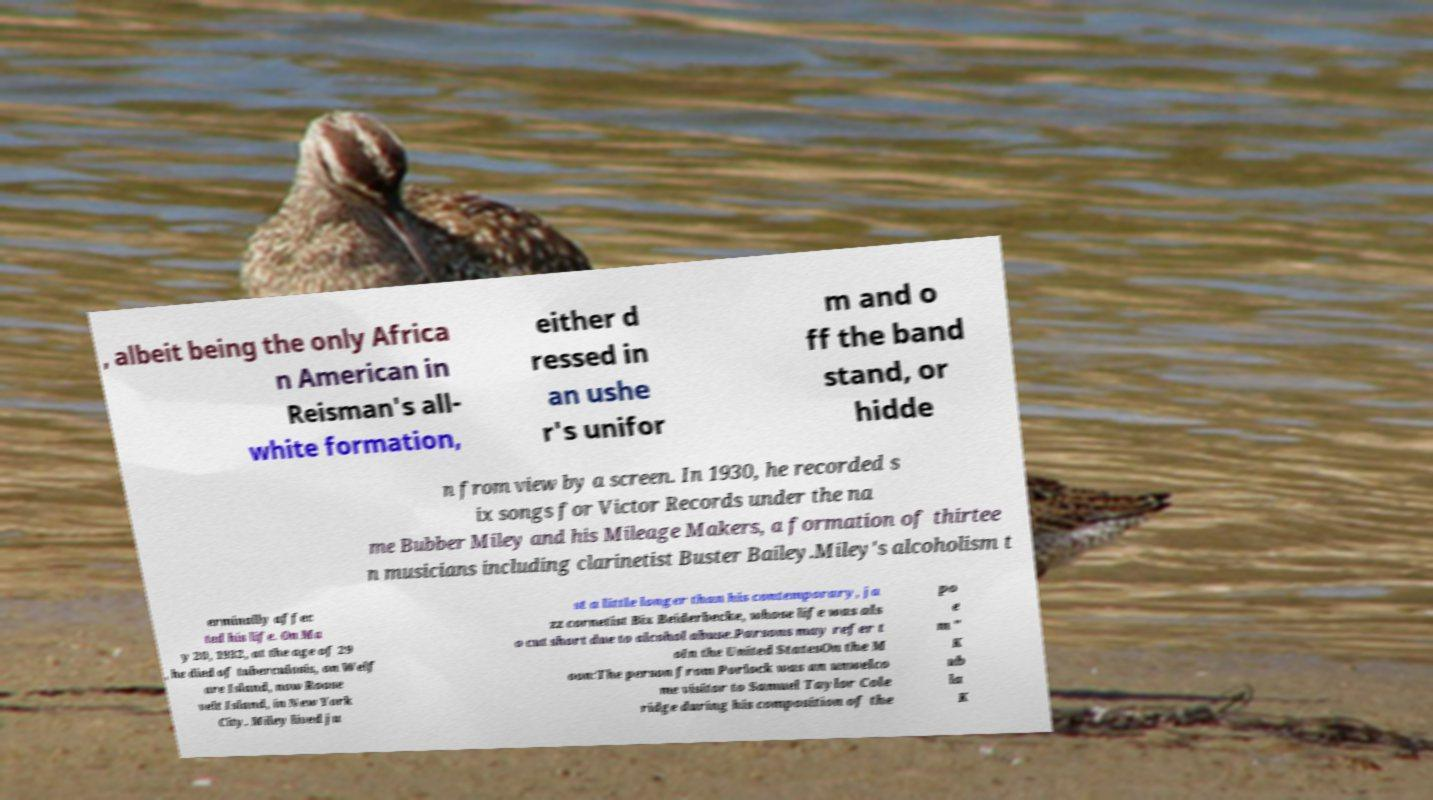Please read and relay the text visible in this image. What does it say? , albeit being the only Africa n American in Reisman's all- white formation, either d ressed in an ushe r's unifor m and o ff the band stand, or hidde n from view by a screen. In 1930, he recorded s ix songs for Victor Records under the na me Bubber Miley and his Mileage Makers, a formation of thirtee n musicians including clarinetist Buster Bailey.Miley's alcoholism t erminally affec ted his life. On Ma y 20, 1932, at the age of 29 , he died of tuberculosis, on Welf are Island, now Roose velt Island, in New York City. Miley lived ju st a little longer than his contemporary, ja zz cornetist Bix Beiderbecke, whose life was als o cut short due to alcohol abuse.Parsons may refer t oIn the United StatesOn the M oon:The person from Porlock was an unwelco me visitor to Samuel Taylor Cole ridge during his composition of the po e m " K ub la K 